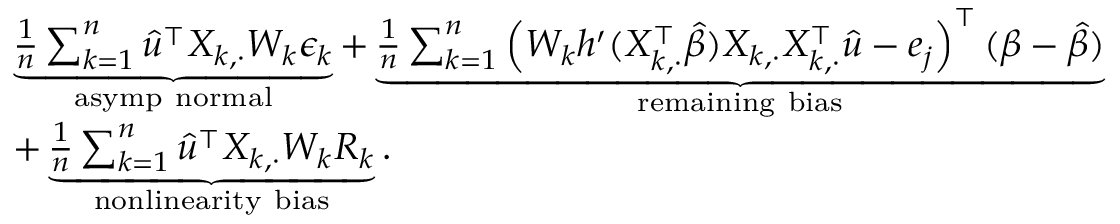Convert formula to latex. <formula><loc_0><loc_0><loc_500><loc_500>\begin{array} { r l } & { \underbrace { \frac { 1 } { n } \sum _ { k = 1 } ^ { n } \widehat { u } ^ { \intercal } X _ { k , \cdot } W _ { k } \epsilon _ { k } } _ { a s y m p n o r m a l } + \underbrace { \frac { 1 } { n } \sum _ { k = 1 } ^ { n } \left ( W _ { k } h ^ { \prime } ( X _ { k , \cdot } ^ { \intercal } \widehat { \beta } ) X _ { k , \cdot } X _ { k , \cdot } ^ { \intercal } \widehat { u } - e _ { j } \right ) ^ { \intercal } ( \beta - \widehat { \beta } ) } _ { r e m a i n i n g b i a s } } \\ & { + \underbrace { \frac { 1 } { n } \sum _ { k = 1 } ^ { n } \widehat { u } ^ { \intercal } X _ { k , \cdot } W _ { k } R _ { k } } _ { n o n l i n e a r i t y b i a s } . } \end{array}</formula> 